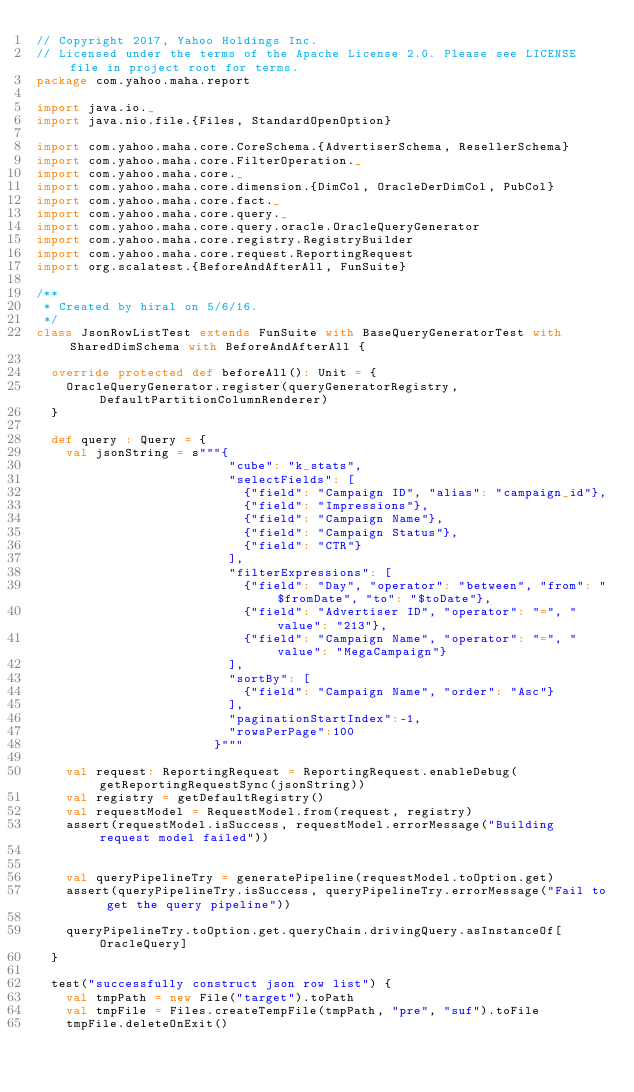Convert code to text. <code><loc_0><loc_0><loc_500><loc_500><_Scala_>// Copyright 2017, Yahoo Holdings Inc.
// Licensed under the terms of the Apache License 2.0. Please see LICENSE file in project root for terms.
package com.yahoo.maha.report

import java.io._
import java.nio.file.{Files, StandardOpenOption}

import com.yahoo.maha.core.CoreSchema.{AdvertiserSchema, ResellerSchema}
import com.yahoo.maha.core.FilterOperation._
import com.yahoo.maha.core._
import com.yahoo.maha.core.dimension.{DimCol, OracleDerDimCol, PubCol}
import com.yahoo.maha.core.fact._
import com.yahoo.maha.core.query._
import com.yahoo.maha.core.query.oracle.OracleQueryGenerator
import com.yahoo.maha.core.registry.RegistryBuilder
import com.yahoo.maha.core.request.ReportingRequest
import org.scalatest.{BeforeAndAfterAll, FunSuite}

/**
 * Created by hiral on 5/6/16.
 */
class JsonRowListTest extends FunSuite with BaseQueryGeneratorTest with SharedDimSchema with BeforeAndAfterAll {

  override protected def beforeAll(): Unit = {
    OracleQueryGenerator.register(queryGeneratorRegistry,DefaultPartitionColumnRenderer)
  }

  def query : Query = {
    val jsonString = s"""{
                          "cube": "k_stats",
                          "selectFields": [
                            {"field": "Campaign ID", "alias": "campaign_id"},
                            {"field": "Impressions"},
                            {"field": "Campaign Name"},
                            {"field": "Campaign Status"},
                            {"field": "CTR"}
                          ],
                          "filterExpressions": [
                            {"field": "Day", "operator": "between", "from": "$fromDate", "to": "$toDate"},
                            {"field": "Advertiser ID", "operator": "=", "value": "213"},
                            {"field": "Campaign Name", "operator": "=", "value": "MegaCampaign"}
                          ],
                          "sortBy": [
                            {"field": "Campaign Name", "order": "Asc"}
                          ],
                          "paginationStartIndex":-1,
                          "rowsPerPage":100
                        }"""

    val request: ReportingRequest = ReportingRequest.enableDebug(getReportingRequestSync(jsonString))
    val registry = getDefaultRegistry()
    val requestModel = RequestModel.from(request, registry)
    assert(requestModel.isSuccess, requestModel.errorMessage("Building request model failed"))


    val queryPipelineTry = generatePipeline(requestModel.toOption.get)
    assert(queryPipelineTry.isSuccess, queryPipelineTry.errorMessage("Fail to get the query pipeline"))

    queryPipelineTry.toOption.get.queryChain.drivingQuery.asInstanceOf[OracleQuery]
  }

  test("successfully construct json row list") {
    val tmpPath = new File("target").toPath
    val tmpFile = Files.createTempFile(tmpPath, "pre", "suf").toFile
    tmpFile.deleteOnExit()</code> 